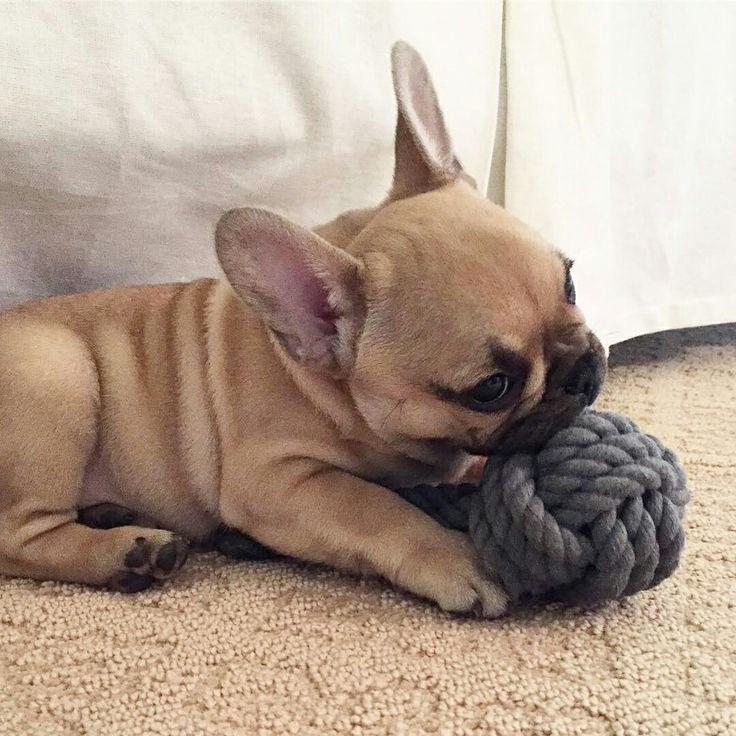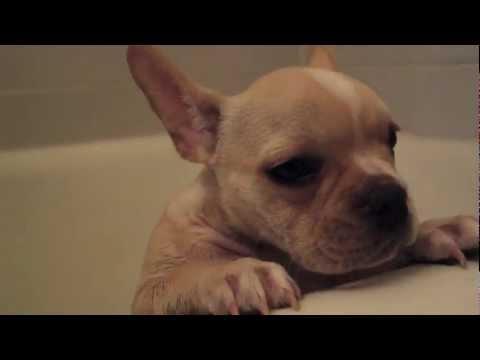The first image is the image on the left, the second image is the image on the right. Examine the images to the left and right. Is the description "In the left image, one white bulldog is alone in a white tub and has its front paws on the rim of the tub." accurate? Answer yes or no. No. The first image is the image on the left, the second image is the image on the right. Assess this claim about the two images: "In one pair, three French bulldogs are in the bathtub, while in the other pair one French bulldog is in the bathtub and two others are outside the tub looking over the side.". Correct or not? Answer yes or no. No. 